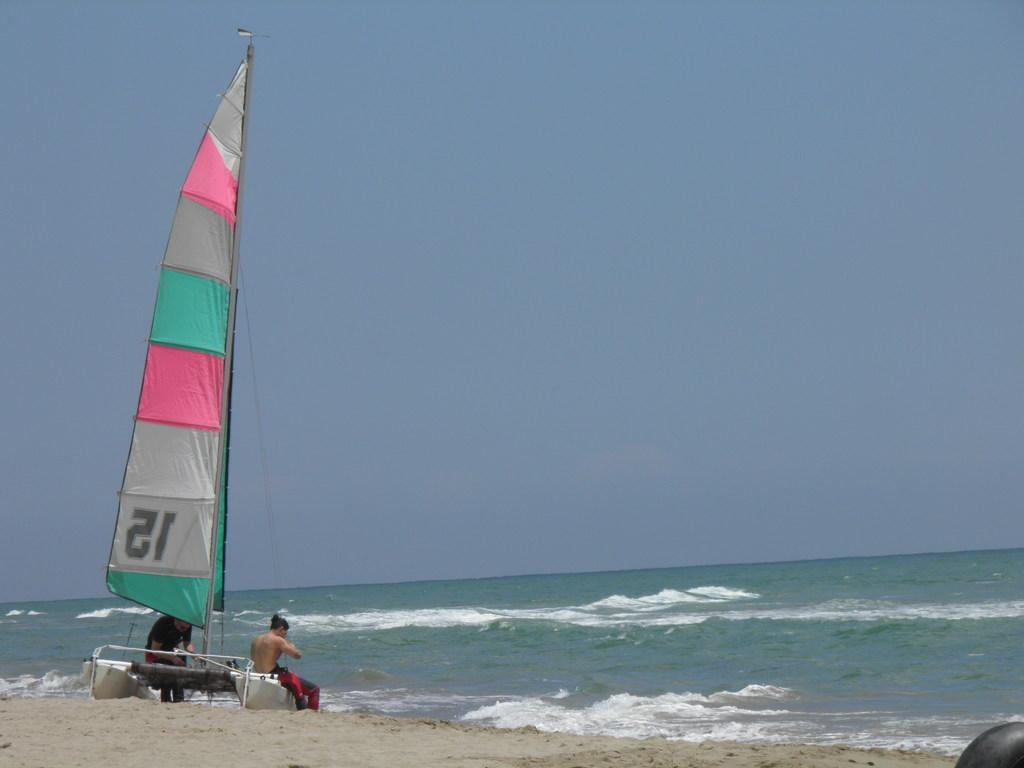What is the main subject of the image? The main subject of the image is a boat. How many people are in the image? There are two persons in the image. Where are the persons located in relation to the boat? The persons are on the sand. What can be seen in front of the persons? There is water visible in front of the persons. How does the boat compare to the army in the image? There is no army present in the image, so it cannot be compared to the boat. 